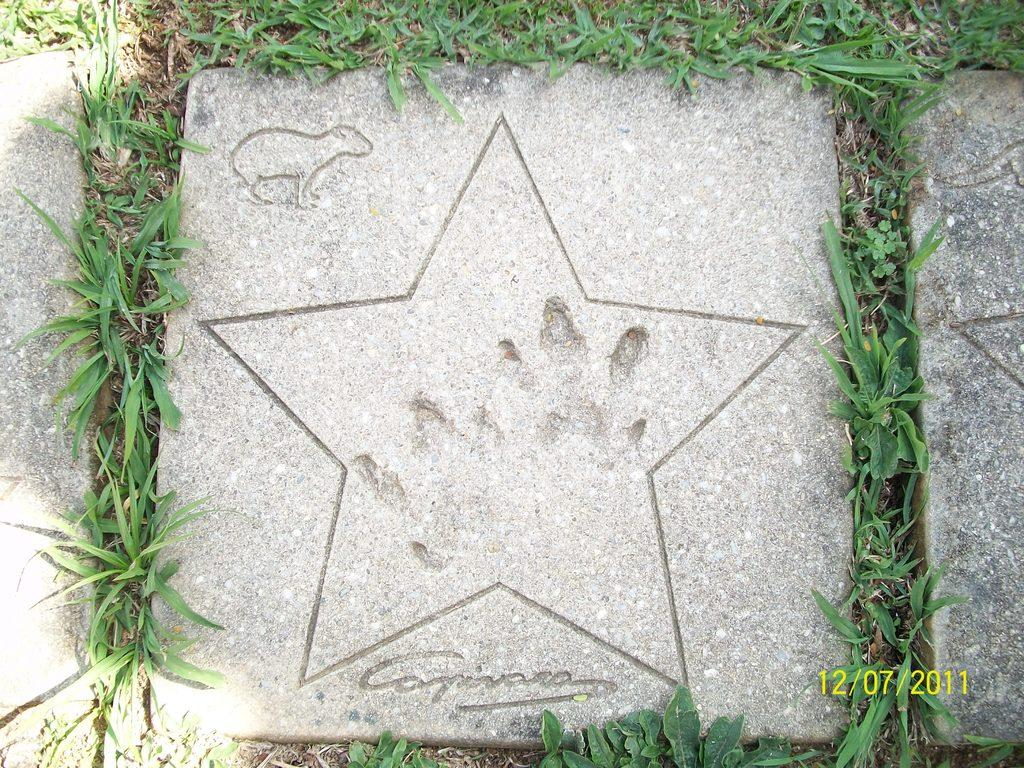What type of surface is on the ground in the image? There is a stone tile on the ground in the image. What surrounds the stone tile? Grass is present on all four sides of the stone tile. What design is engraved on the stone tile? There is a star and an animal engraved on the stone tile. Can you describe any marks or impressions on the stone tile? Fingerprints are visible on the stone tile. What type of headwear is the animal wearing in the image? There is no animal wearing headwear in the image, as the animal is engraved on the stone tile. 